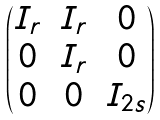<formula> <loc_0><loc_0><loc_500><loc_500>\begin{pmatrix} I _ { r } & I _ { r } & 0 \\ 0 & I _ { r } & 0 \\ 0 & 0 & I _ { 2 s } \end{pmatrix}</formula> 